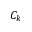Convert formula to latex. <formula><loc_0><loc_0><loc_500><loc_500>C _ { k }</formula> 